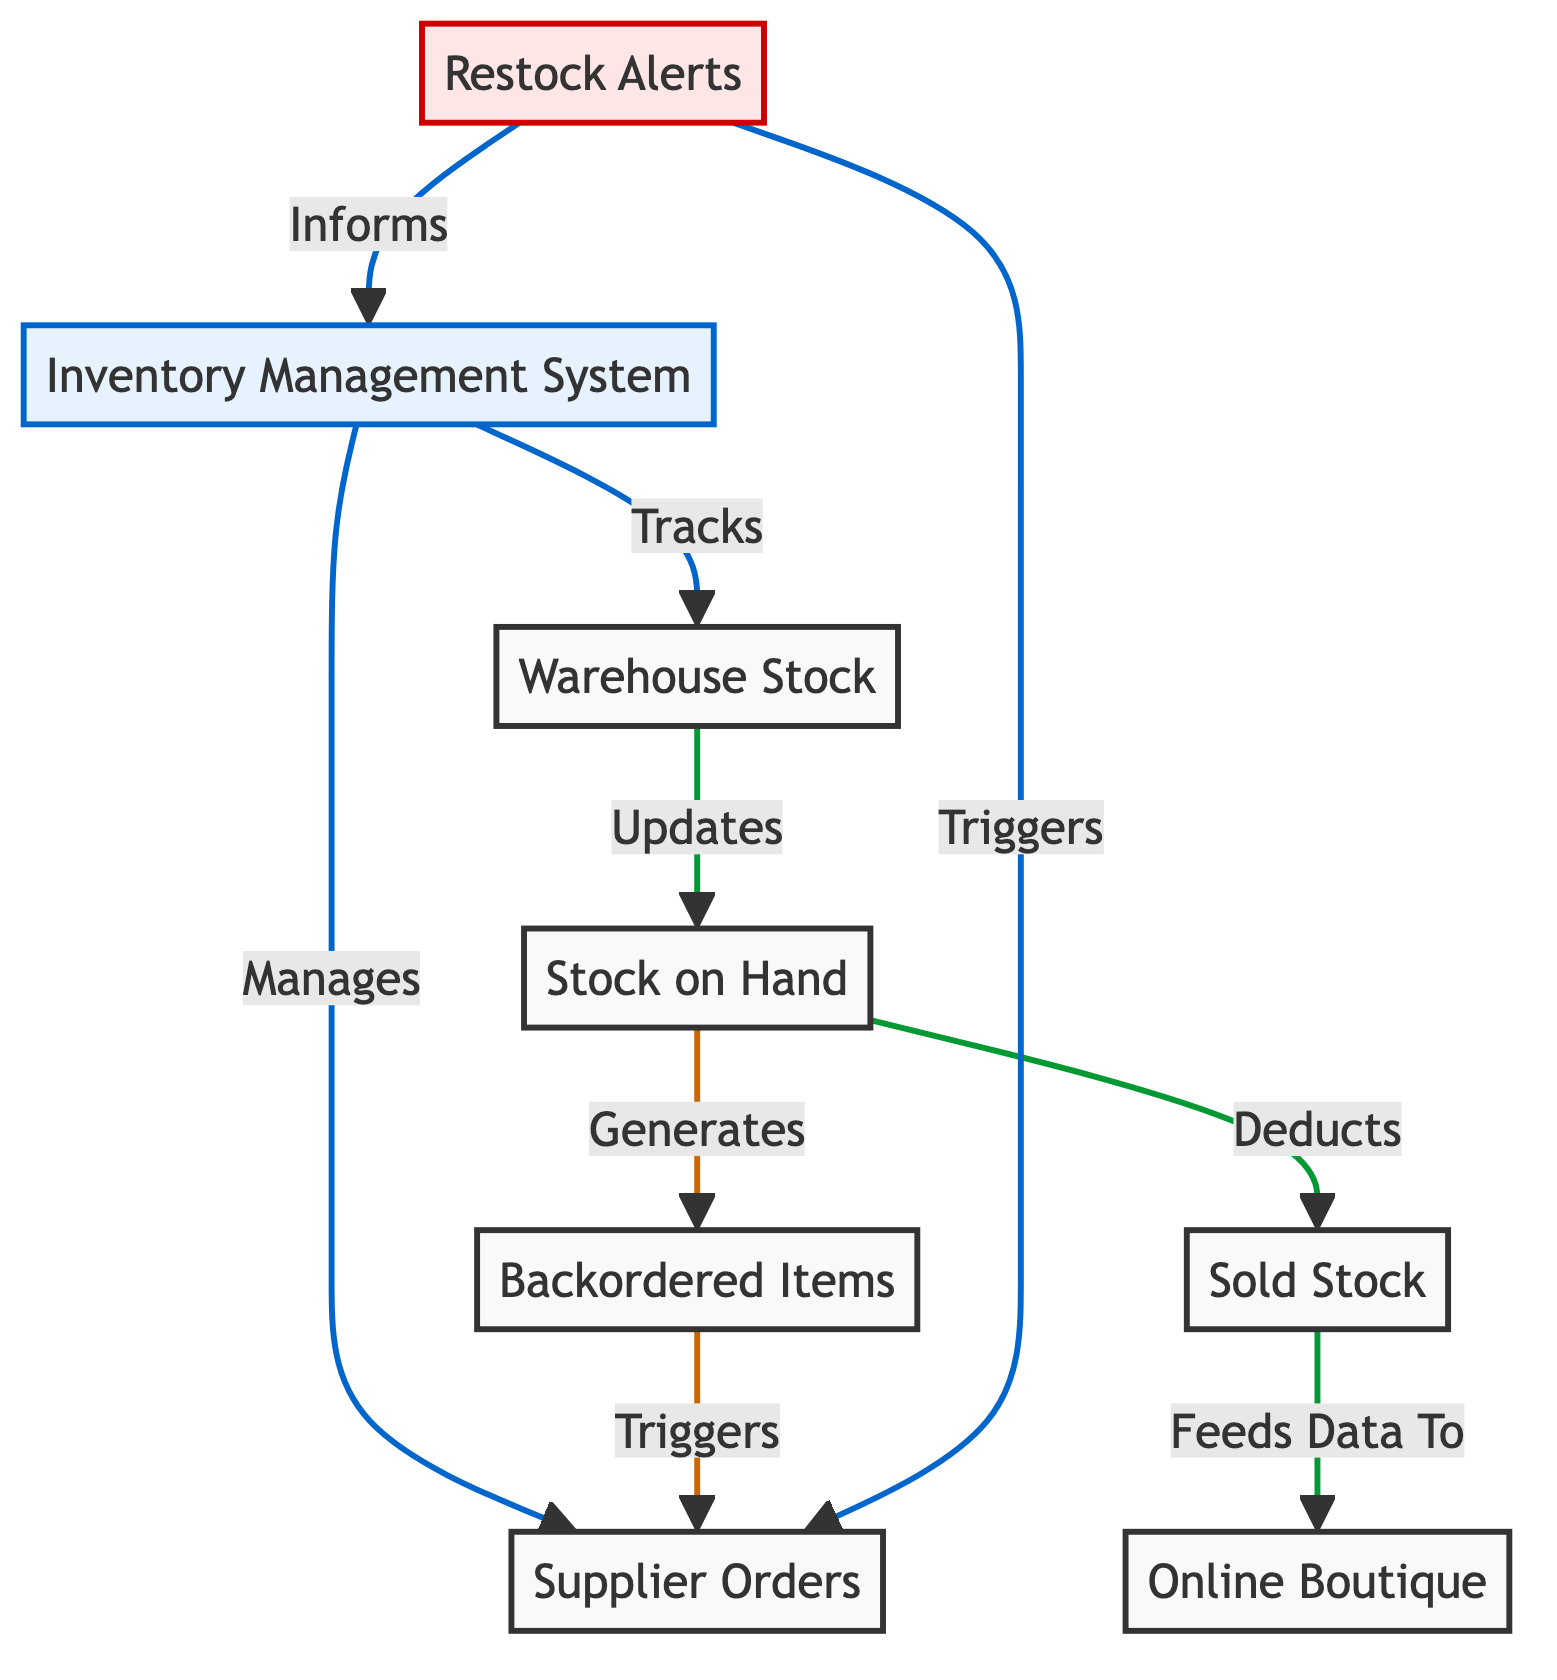What is the main function of the Inventory Management System? The main function indicated in the diagram is to manage supplier orders and track warehouse stock. This is stated clearly with the label "Inventory Management System" pointing to the actions of managing and tracking.
Answer: Manages supplier orders and tracks warehouse stock How many nodes are present in the diagram? By counting the distinct nodes in the diagram, we find there are a total of 8 nodes: Inventory Management System, Supplier Orders, Warehouse Stock, Stock on Hand, Sold Stock, Online Boutique, Backordered Items, and Restock Alerts.
Answer: 8 What happens when stock on hand generates backordered items? The diagram shows that when stock on hand generates backordered items, it triggers supplier orders. This means that a decrease in stock on hand can initiate an order with suppliers to replenish stock.
Answer: Triggers supplier orders Which node receives data from sold stock? According to the flow outlined in the diagram, the sold stock feeds data directly to the online boutique, indicating that sales data is being conveyed to that node for updates or management.
Answer: Online Boutique What action does the restock alert perform? The restock alert performs two main actions in the diagram: it triggers supplier orders and informs the inventory management system, indicating that it serves a dual purpose in notifying both suppliers and the management system about low stock levels.
Answer: Triggers supplier orders and informs the inventory management system How does warehouse stock relate to stock on hand? Warehouse stock updates stock on hand in the diagram flow, which indicates that the data regarding the amount of stock stored in the warehouse is continually informing and adjusting the actual stock levels available for sales or distribution.
Answer: Updates stock on hand What type of alert is indicated in the diagram? The alert type indicated in the diagram is a restock alert, which is displayed distinctly with a specific coloring and actions related to inventory management processes, highlighting its importance in notification chains.
Answer: Restock alert Which node represents sold stock? The node representing sold stock is explicitly labeled as "Sold Stock" in the diagram, indicating it as a distinct entity reflecting items that have been sold and are no longer available in the stock on hand.
Answer: Sold Stock 